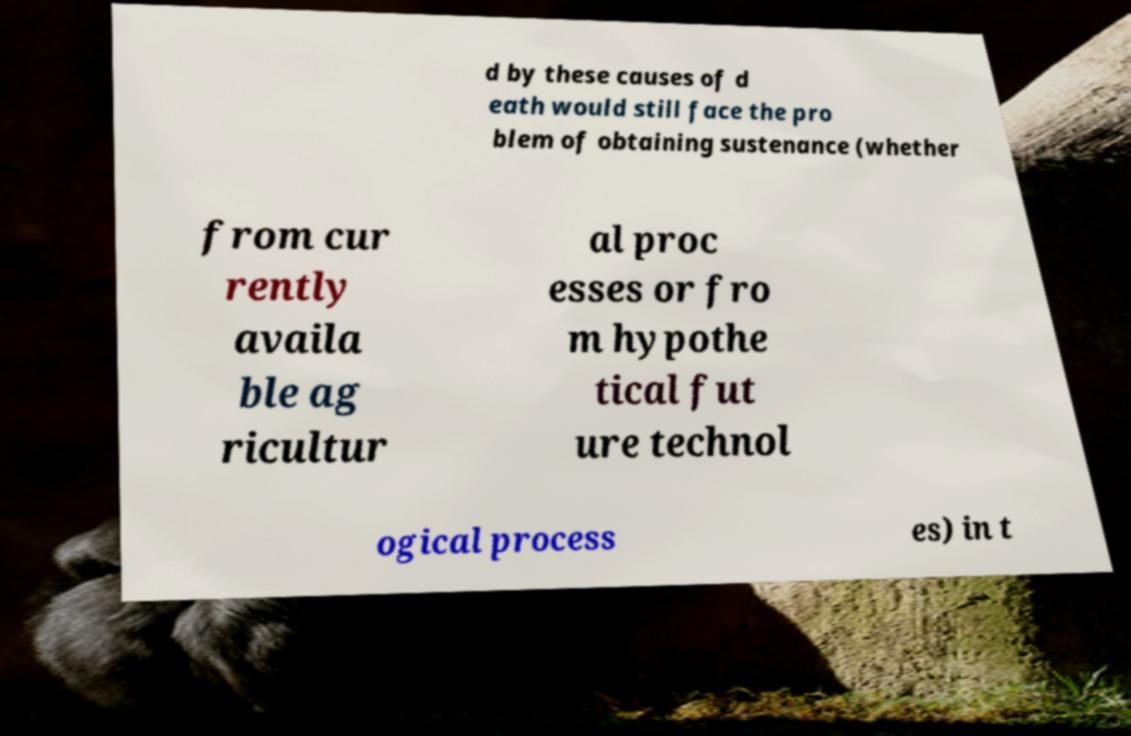I need the written content from this picture converted into text. Can you do that? d by these causes of d eath would still face the pro blem of obtaining sustenance (whether from cur rently availa ble ag ricultur al proc esses or fro m hypothe tical fut ure technol ogical process es) in t 